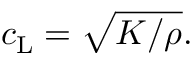Convert formula to latex. <formula><loc_0><loc_0><loc_500><loc_500>c _ { L } = \sqrt { K / \rho } .</formula> 